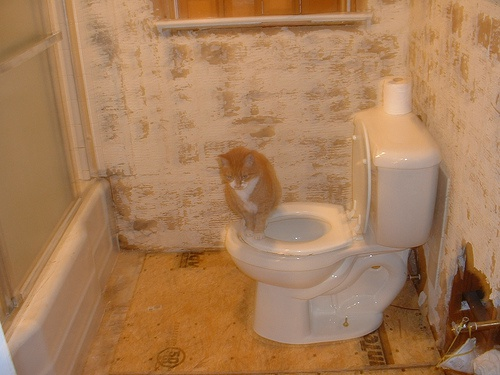Describe the objects in this image and their specific colors. I can see toilet in olive, gray, darkgray, and tan tones and cat in olive, brown, and gray tones in this image. 